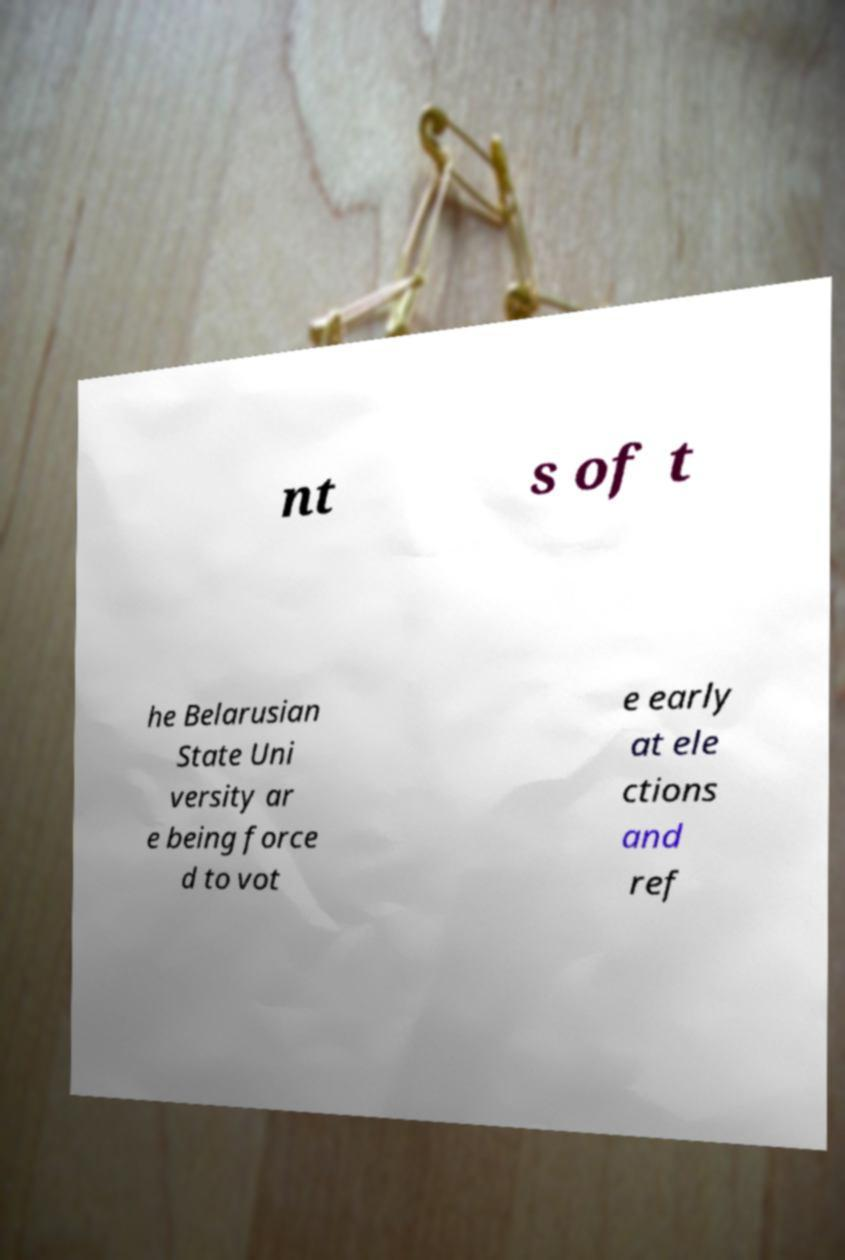There's text embedded in this image that I need extracted. Can you transcribe it verbatim? nt s of t he Belarusian State Uni versity ar e being force d to vot e early at ele ctions and ref 